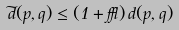<formula> <loc_0><loc_0><loc_500><loc_500>\widetilde { d } ( p , q ) \leq ( 1 + \epsilon ) \, d ( p , q )</formula> 